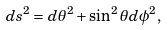Convert formula to latex. <formula><loc_0><loc_0><loc_500><loc_500>d s ^ { 2 } = d \theta ^ { 2 } + \sin ^ { 2 } \theta d \phi ^ { 2 } ,</formula> 